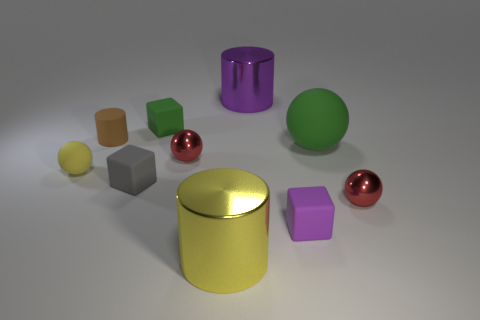Subtract all small brown cylinders. How many cylinders are left? 2 Subtract all purple cubes. How many cubes are left? 2 Add 3 green blocks. How many green blocks exist? 4 Subtract 1 red balls. How many objects are left? 9 Subtract all spheres. How many objects are left? 6 Subtract 1 cylinders. How many cylinders are left? 2 Subtract all purple spheres. Subtract all cyan blocks. How many spheres are left? 4 Subtract all purple blocks. How many red spheres are left? 2 Subtract all purple matte objects. Subtract all small metallic blocks. How many objects are left? 9 Add 8 large matte balls. How many large matte balls are left? 9 